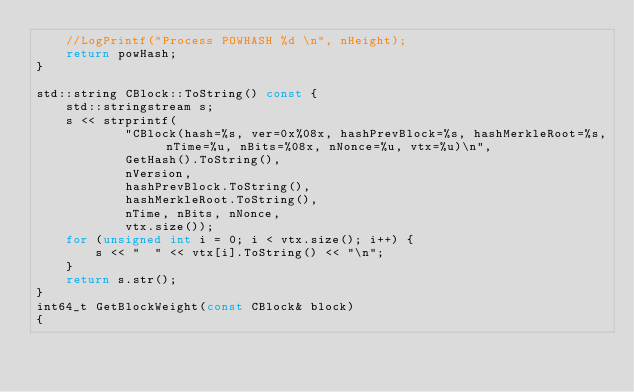<code> <loc_0><loc_0><loc_500><loc_500><_C++_>    //LogPrintf("Process POWHASH %d \n", nHeight);
    return powHash;
}

std::string CBlock::ToString() const {
    std::stringstream s;
    s << strprintf(
            "CBlock(hash=%s, ver=0x%08x, hashPrevBlock=%s, hashMerkleRoot=%s, nTime=%u, nBits=%08x, nNonce=%u, vtx=%u)\n",
            GetHash().ToString(),
            nVersion,
            hashPrevBlock.ToString(),
            hashMerkleRoot.ToString(),
            nTime, nBits, nNonce,
            vtx.size());
    for (unsigned int i = 0; i < vtx.size(); i++) {
        s << "  " << vtx[i].ToString() << "\n";
    }
    return s.str();
}
int64_t GetBlockWeight(const CBlock& block)
{</code> 